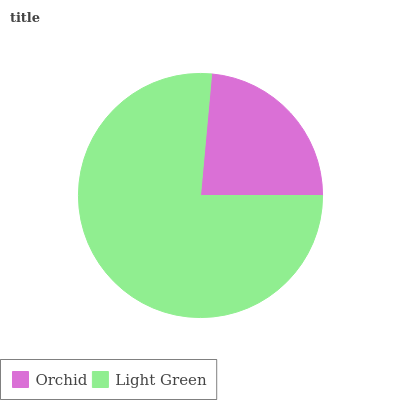Is Orchid the minimum?
Answer yes or no. Yes. Is Light Green the maximum?
Answer yes or no. Yes. Is Light Green the minimum?
Answer yes or no. No. Is Light Green greater than Orchid?
Answer yes or no. Yes. Is Orchid less than Light Green?
Answer yes or no. Yes. Is Orchid greater than Light Green?
Answer yes or no. No. Is Light Green less than Orchid?
Answer yes or no. No. Is Light Green the high median?
Answer yes or no. Yes. Is Orchid the low median?
Answer yes or no. Yes. Is Orchid the high median?
Answer yes or no. No. Is Light Green the low median?
Answer yes or no. No. 